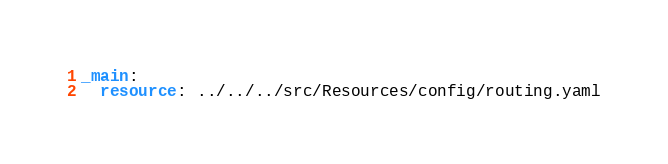Convert code to text. <code><loc_0><loc_0><loc_500><loc_500><_YAML_>_main:
  resource: ../../../src/Resources/config/routing.yaml</code> 